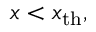<formula> <loc_0><loc_0><loc_500><loc_500>x < x _ { t h } ,</formula> 